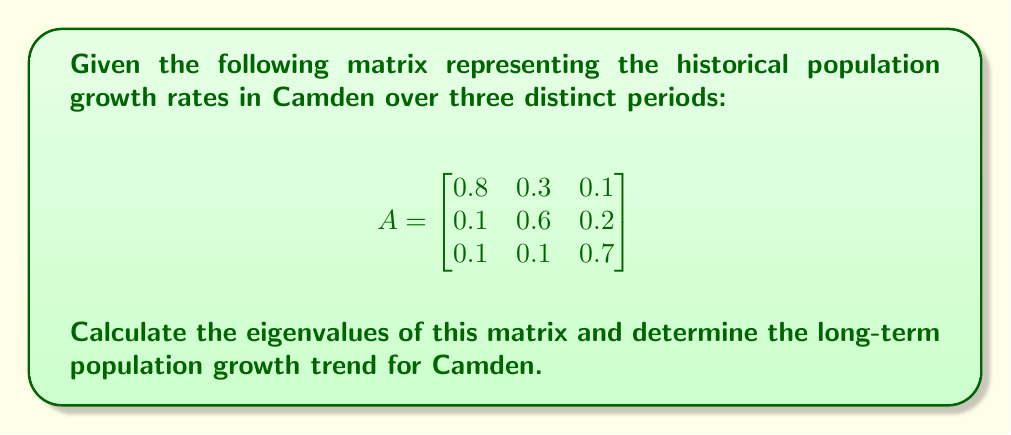Teach me how to tackle this problem. To find the eigenvalues of matrix A, we need to solve the characteristic equation:

1) First, we calculate $det(A - \lambda I)$:

   $$det\begin{pmatrix}
   0.8-\lambda & 0.3 & 0.1 \\
   0.1 & 0.6-\lambda & 0.2 \\
   0.1 & 0.1 & 0.7-\lambda
   \end{pmatrix} = 0$$

2) Expanding the determinant:
   
   $(0.8-\lambda)[(0.6-\lambda)(0.7-\lambda)-0.02] - 0.3[0.1(0.7-\lambda)-0.02] + 0.1[0.1(0.6-\lambda)-0.02] = 0$

3) Simplifying:
   
   $-\lambda^3 + 2.1\lambda^2 - 1.41\lambda + 0.3 = 0$

4) This cubic equation can be solved using various methods. Using a computer algebra system or numerical methods, we find the roots:

   $\lambda_1 \approx 1$
   $\lambda_2 \approx 0.7$
   $\lambda_3 \approx 0.4$

5) The largest eigenvalue, $\lambda_1 \approx 1$, determines the long-term growth trend. Since it's approximately 1, this indicates that Camden's population will likely stabilize in the long term, neither growing nor declining significantly.
Answer: Eigenvalues: $\lambda_1 \approx 1$, $\lambda_2 \approx 0.7$, $\lambda_3 \approx 0.4$. Long-term trend: population stabilization. 